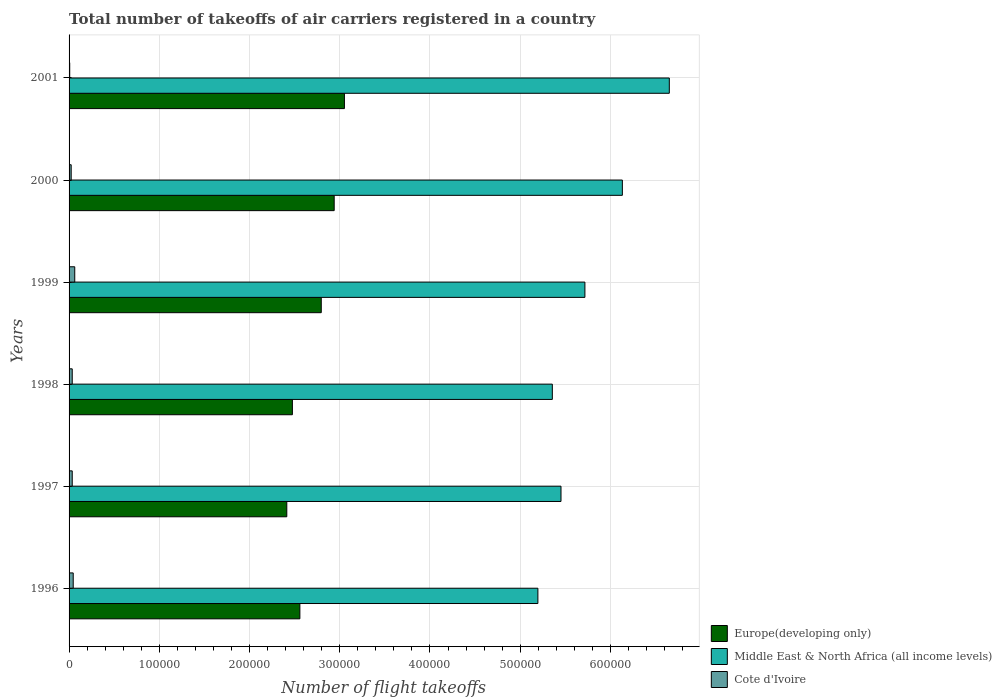How many groups of bars are there?
Offer a terse response. 6. Are the number of bars on each tick of the Y-axis equal?
Provide a succinct answer. Yes. How many bars are there on the 3rd tick from the top?
Your answer should be compact. 3. What is the total number of flight takeoffs in Europe(developing only) in 1996?
Offer a terse response. 2.56e+05. Across all years, what is the maximum total number of flight takeoffs in Middle East & North Africa (all income levels)?
Give a very brief answer. 6.65e+05. Across all years, what is the minimum total number of flight takeoffs in Middle East & North Africa (all income levels)?
Your answer should be compact. 5.20e+05. In which year was the total number of flight takeoffs in Cote d'Ivoire minimum?
Ensure brevity in your answer.  2001. What is the total total number of flight takeoffs in Middle East & North Africa (all income levels) in the graph?
Give a very brief answer. 3.45e+06. What is the difference between the total number of flight takeoffs in Cote d'Ivoire in 1997 and that in 1998?
Make the answer very short. 0. What is the difference between the total number of flight takeoffs in Europe(developing only) in 2000 and the total number of flight takeoffs in Cote d'Ivoire in 2001?
Your answer should be compact. 2.93e+05. What is the average total number of flight takeoffs in Middle East & North Africa (all income levels) per year?
Your response must be concise. 5.75e+05. In the year 1999, what is the difference between the total number of flight takeoffs in Europe(developing only) and total number of flight takeoffs in Middle East & North Africa (all income levels)?
Your response must be concise. -2.92e+05. What is the ratio of the total number of flight takeoffs in Middle East & North Africa (all income levels) in 1998 to that in 1999?
Make the answer very short. 0.94. Is the difference between the total number of flight takeoffs in Europe(developing only) in 1997 and 2001 greater than the difference between the total number of flight takeoffs in Middle East & North Africa (all income levels) in 1997 and 2001?
Make the answer very short. Yes. What is the difference between the highest and the second highest total number of flight takeoffs in Cote d'Ivoire?
Give a very brief answer. 1700. What is the difference between the highest and the lowest total number of flight takeoffs in Cote d'Ivoire?
Your answer should be very brief. 5584. What does the 2nd bar from the top in 1999 represents?
Provide a succinct answer. Middle East & North Africa (all income levels). What does the 3rd bar from the bottom in 1997 represents?
Your answer should be compact. Cote d'Ivoire. How many bars are there?
Offer a very short reply. 18. How many years are there in the graph?
Your answer should be very brief. 6. What is the difference between two consecutive major ticks on the X-axis?
Offer a terse response. 1.00e+05. Does the graph contain grids?
Offer a terse response. Yes. Where does the legend appear in the graph?
Your response must be concise. Bottom right. How many legend labels are there?
Provide a short and direct response. 3. How are the legend labels stacked?
Ensure brevity in your answer.  Vertical. What is the title of the graph?
Offer a very short reply. Total number of takeoffs of air carriers registered in a country. Does "New Zealand" appear as one of the legend labels in the graph?
Give a very brief answer. No. What is the label or title of the X-axis?
Give a very brief answer. Number of flight takeoffs. What is the Number of flight takeoffs in Europe(developing only) in 1996?
Offer a very short reply. 2.56e+05. What is the Number of flight takeoffs of Middle East & North Africa (all income levels) in 1996?
Keep it short and to the point. 5.20e+05. What is the Number of flight takeoffs in Cote d'Ivoire in 1996?
Your answer should be very brief. 4600. What is the Number of flight takeoffs of Europe(developing only) in 1997?
Ensure brevity in your answer.  2.41e+05. What is the Number of flight takeoffs of Middle East & North Africa (all income levels) in 1997?
Offer a very short reply. 5.45e+05. What is the Number of flight takeoffs in Cote d'Ivoire in 1997?
Ensure brevity in your answer.  3500. What is the Number of flight takeoffs of Europe(developing only) in 1998?
Make the answer very short. 2.48e+05. What is the Number of flight takeoffs in Middle East & North Africa (all income levels) in 1998?
Your answer should be compact. 5.36e+05. What is the Number of flight takeoffs of Cote d'Ivoire in 1998?
Make the answer very short. 3500. What is the Number of flight takeoffs of Europe(developing only) in 1999?
Your answer should be very brief. 2.80e+05. What is the Number of flight takeoffs in Middle East & North Africa (all income levels) in 1999?
Offer a terse response. 5.72e+05. What is the Number of flight takeoffs of Cote d'Ivoire in 1999?
Provide a succinct answer. 6300. What is the Number of flight takeoffs of Europe(developing only) in 2000?
Ensure brevity in your answer.  2.94e+05. What is the Number of flight takeoffs of Middle East & North Africa (all income levels) in 2000?
Offer a very short reply. 6.13e+05. What is the Number of flight takeoffs of Cote d'Ivoire in 2000?
Ensure brevity in your answer.  2342. What is the Number of flight takeoffs in Europe(developing only) in 2001?
Your response must be concise. 3.05e+05. What is the Number of flight takeoffs in Middle East & North Africa (all income levels) in 2001?
Give a very brief answer. 6.65e+05. What is the Number of flight takeoffs in Cote d'Ivoire in 2001?
Offer a terse response. 716. Across all years, what is the maximum Number of flight takeoffs of Europe(developing only)?
Provide a short and direct response. 3.05e+05. Across all years, what is the maximum Number of flight takeoffs in Middle East & North Africa (all income levels)?
Give a very brief answer. 6.65e+05. Across all years, what is the maximum Number of flight takeoffs in Cote d'Ivoire?
Make the answer very short. 6300. Across all years, what is the minimum Number of flight takeoffs of Europe(developing only)?
Provide a short and direct response. 2.41e+05. Across all years, what is the minimum Number of flight takeoffs in Middle East & North Africa (all income levels)?
Provide a short and direct response. 5.20e+05. Across all years, what is the minimum Number of flight takeoffs in Cote d'Ivoire?
Make the answer very short. 716. What is the total Number of flight takeoffs of Europe(developing only) in the graph?
Your response must be concise. 1.62e+06. What is the total Number of flight takeoffs of Middle East & North Africa (all income levels) in the graph?
Offer a very short reply. 3.45e+06. What is the total Number of flight takeoffs in Cote d'Ivoire in the graph?
Your response must be concise. 2.10e+04. What is the difference between the Number of flight takeoffs of Europe(developing only) in 1996 and that in 1997?
Offer a very short reply. 1.45e+04. What is the difference between the Number of flight takeoffs of Middle East & North Africa (all income levels) in 1996 and that in 1997?
Provide a short and direct response. -2.56e+04. What is the difference between the Number of flight takeoffs in Cote d'Ivoire in 1996 and that in 1997?
Make the answer very short. 1100. What is the difference between the Number of flight takeoffs of Europe(developing only) in 1996 and that in 1998?
Your response must be concise. 8300. What is the difference between the Number of flight takeoffs of Middle East & North Africa (all income levels) in 1996 and that in 1998?
Your answer should be very brief. -1.60e+04. What is the difference between the Number of flight takeoffs in Cote d'Ivoire in 1996 and that in 1998?
Your answer should be very brief. 1100. What is the difference between the Number of flight takeoffs of Europe(developing only) in 1996 and that in 1999?
Make the answer very short. -2.37e+04. What is the difference between the Number of flight takeoffs of Middle East & North Africa (all income levels) in 1996 and that in 1999?
Make the answer very short. -5.21e+04. What is the difference between the Number of flight takeoffs in Cote d'Ivoire in 1996 and that in 1999?
Ensure brevity in your answer.  -1700. What is the difference between the Number of flight takeoffs of Europe(developing only) in 1996 and that in 2000?
Keep it short and to the point. -3.80e+04. What is the difference between the Number of flight takeoffs in Middle East & North Africa (all income levels) in 1996 and that in 2000?
Your answer should be very brief. -9.36e+04. What is the difference between the Number of flight takeoffs in Cote d'Ivoire in 1996 and that in 2000?
Keep it short and to the point. 2258. What is the difference between the Number of flight takeoffs in Europe(developing only) in 1996 and that in 2001?
Make the answer very short. -4.94e+04. What is the difference between the Number of flight takeoffs of Middle East & North Africa (all income levels) in 1996 and that in 2001?
Ensure brevity in your answer.  -1.46e+05. What is the difference between the Number of flight takeoffs of Cote d'Ivoire in 1996 and that in 2001?
Give a very brief answer. 3884. What is the difference between the Number of flight takeoffs in Europe(developing only) in 1997 and that in 1998?
Ensure brevity in your answer.  -6200. What is the difference between the Number of flight takeoffs in Middle East & North Africa (all income levels) in 1997 and that in 1998?
Your response must be concise. 9600. What is the difference between the Number of flight takeoffs in Cote d'Ivoire in 1997 and that in 1998?
Your answer should be compact. 0. What is the difference between the Number of flight takeoffs of Europe(developing only) in 1997 and that in 1999?
Offer a terse response. -3.82e+04. What is the difference between the Number of flight takeoffs in Middle East & North Africa (all income levels) in 1997 and that in 1999?
Offer a very short reply. -2.65e+04. What is the difference between the Number of flight takeoffs in Cote d'Ivoire in 1997 and that in 1999?
Ensure brevity in your answer.  -2800. What is the difference between the Number of flight takeoffs of Europe(developing only) in 1997 and that in 2000?
Offer a terse response. -5.25e+04. What is the difference between the Number of flight takeoffs of Middle East & North Africa (all income levels) in 1997 and that in 2000?
Your answer should be very brief. -6.80e+04. What is the difference between the Number of flight takeoffs in Cote d'Ivoire in 1997 and that in 2000?
Your response must be concise. 1158. What is the difference between the Number of flight takeoffs in Europe(developing only) in 1997 and that in 2001?
Your answer should be very brief. -6.39e+04. What is the difference between the Number of flight takeoffs of Middle East & North Africa (all income levels) in 1997 and that in 2001?
Offer a very short reply. -1.20e+05. What is the difference between the Number of flight takeoffs in Cote d'Ivoire in 1997 and that in 2001?
Your response must be concise. 2784. What is the difference between the Number of flight takeoffs in Europe(developing only) in 1998 and that in 1999?
Provide a succinct answer. -3.20e+04. What is the difference between the Number of flight takeoffs in Middle East & North Africa (all income levels) in 1998 and that in 1999?
Make the answer very short. -3.61e+04. What is the difference between the Number of flight takeoffs of Cote d'Ivoire in 1998 and that in 1999?
Give a very brief answer. -2800. What is the difference between the Number of flight takeoffs in Europe(developing only) in 1998 and that in 2000?
Provide a succinct answer. -4.63e+04. What is the difference between the Number of flight takeoffs of Middle East & North Africa (all income levels) in 1998 and that in 2000?
Your response must be concise. -7.76e+04. What is the difference between the Number of flight takeoffs of Cote d'Ivoire in 1998 and that in 2000?
Your answer should be very brief. 1158. What is the difference between the Number of flight takeoffs in Europe(developing only) in 1998 and that in 2001?
Your answer should be very brief. -5.77e+04. What is the difference between the Number of flight takeoffs in Middle East & North Africa (all income levels) in 1998 and that in 2001?
Provide a succinct answer. -1.30e+05. What is the difference between the Number of flight takeoffs in Cote d'Ivoire in 1998 and that in 2001?
Your answer should be very brief. 2784. What is the difference between the Number of flight takeoffs of Europe(developing only) in 1999 and that in 2000?
Your answer should be compact. -1.43e+04. What is the difference between the Number of flight takeoffs in Middle East & North Africa (all income levels) in 1999 and that in 2000?
Ensure brevity in your answer.  -4.15e+04. What is the difference between the Number of flight takeoffs of Cote d'Ivoire in 1999 and that in 2000?
Offer a very short reply. 3958. What is the difference between the Number of flight takeoffs in Europe(developing only) in 1999 and that in 2001?
Provide a succinct answer. -2.57e+04. What is the difference between the Number of flight takeoffs in Middle East & North Africa (all income levels) in 1999 and that in 2001?
Your answer should be compact. -9.35e+04. What is the difference between the Number of flight takeoffs in Cote d'Ivoire in 1999 and that in 2001?
Offer a terse response. 5584. What is the difference between the Number of flight takeoffs in Europe(developing only) in 2000 and that in 2001?
Offer a terse response. -1.13e+04. What is the difference between the Number of flight takeoffs in Middle East & North Africa (all income levels) in 2000 and that in 2001?
Offer a very short reply. -5.20e+04. What is the difference between the Number of flight takeoffs of Cote d'Ivoire in 2000 and that in 2001?
Offer a terse response. 1626. What is the difference between the Number of flight takeoffs in Europe(developing only) in 1996 and the Number of flight takeoffs in Middle East & North Africa (all income levels) in 1997?
Your response must be concise. -2.89e+05. What is the difference between the Number of flight takeoffs in Europe(developing only) in 1996 and the Number of flight takeoffs in Cote d'Ivoire in 1997?
Your answer should be compact. 2.52e+05. What is the difference between the Number of flight takeoffs of Middle East & North Africa (all income levels) in 1996 and the Number of flight takeoffs of Cote d'Ivoire in 1997?
Provide a short and direct response. 5.16e+05. What is the difference between the Number of flight takeoffs in Europe(developing only) in 1996 and the Number of flight takeoffs in Middle East & North Africa (all income levels) in 1998?
Provide a short and direct response. -2.80e+05. What is the difference between the Number of flight takeoffs of Europe(developing only) in 1996 and the Number of flight takeoffs of Cote d'Ivoire in 1998?
Your answer should be very brief. 2.52e+05. What is the difference between the Number of flight takeoffs of Middle East & North Africa (all income levels) in 1996 and the Number of flight takeoffs of Cote d'Ivoire in 1998?
Your answer should be very brief. 5.16e+05. What is the difference between the Number of flight takeoffs in Europe(developing only) in 1996 and the Number of flight takeoffs in Middle East & North Africa (all income levels) in 1999?
Offer a very short reply. -3.16e+05. What is the difference between the Number of flight takeoffs in Europe(developing only) in 1996 and the Number of flight takeoffs in Cote d'Ivoire in 1999?
Provide a succinct answer. 2.50e+05. What is the difference between the Number of flight takeoffs in Middle East & North Africa (all income levels) in 1996 and the Number of flight takeoffs in Cote d'Ivoire in 1999?
Your response must be concise. 5.13e+05. What is the difference between the Number of flight takeoffs of Europe(developing only) in 1996 and the Number of flight takeoffs of Middle East & North Africa (all income levels) in 2000?
Offer a terse response. -3.57e+05. What is the difference between the Number of flight takeoffs of Europe(developing only) in 1996 and the Number of flight takeoffs of Cote d'Ivoire in 2000?
Keep it short and to the point. 2.53e+05. What is the difference between the Number of flight takeoffs of Middle East & North Africa (all income levels) in 1996 and the Number of flight takeoffs of Cote d'Ivoire in 2000?
Offer a terse response. 5.17e+05. What is the difference between the Number of flight takeoffs of Europe(developing only) in 1996 and the Number of flight takeoffs of Middle East & North Africa (all income levels) in 2001?
Ensure brevity in your answer.  -4.09e+05. What is the difference between the Number of flight takeoffs of Europe(developing only) in 1996 and the Number of flight takeoffs of Cote d'Ivoire in 2001?
Offer a very short reply. 2.55e+05. What is the difference between the Number of flight takeoffs of Middle East & North Africa (all income levels) in 1996 and the Number of flight takeoffs of Cote d'Ivoire in 2001?
Provide a succinct answer. 5.19e+05. What is the difference between the Number of flight takeoffs in Europe(developing only) in 1997 and the Number of flight takeoffs in Middle East & North Africa (all income levels) in 1998?
Ensure brevity in your answer.  -2.94e+05. What is the difference between the Number of flight takeoffs in Europe(developing only) in 1997 and the Number of flight takeoffs in Cote d'Ivoire in 1998?
Give a very brief answer. 2.38e+05. What is the difference between the Number of flight takeoffs of Middle East & North Africa (all income levels) in 1997 and the Number of flight takeoffs of Cote d'Ivoire in 1998?
Your response must be concise. 5.42e+05. What is the difference between the Number of flight takeoffs of Europe(developing only) in 1997 and the Number of flight takeoffs of Middle East & North Africa (all income levels) in 1999?
Give a very brief answer. -3.30e+05. What is the difference between the Number of flight takeoffs in Europe(developing only) in 1997 and the Number of flight takeoffs in Cote d'Ivoire in 1999?
Your answer should be very brief. 2.35e+05. What is the difference between the Number of flight takeoffs in Middle East & North Africa (all income levels) in 1997 and the Number of flight takeoffs in Cote d'Ivoire in 1999?
Your response must be concise. 5.39e+05. What is the difference between the Number of flight takeoffs of Europe(developing only) in 1997 and the Number of flight takeoffs of Middle East & North Africa (all income levels) in 2000?
Provide a short and direct response. -3.72e+05. What is the difference between the Number of flight takeoffs in Europe(developing only) in 1997 and the Number of flight takeoffs in Cote d'Ivoire in 2000?
Provide a short and direct response. 2.39e+05. What is the difference between the Number of flight takeoffs of Middle East & North Africa (all income levels) in 1997 and the Number of flight takeoffs of Cote d'Ivoire in 2000?
Keep it short and to the point. 5.43e+05. What is the difference between the Number of flight takeoffs of Europe(developing only) in 1997 and the Number of flight takeoffs of Middle East & North Africa (all income levels) in 2001?
Provide a short and direct response. -4.24e+05. What is the difference between the Number of flight takeoffs in Europe(developing only) in 1997 and the Number of flight takeoffs in Cote d'Ivoire in 2001?
Offer a very short reply. 2.41e+05. What is the difference between the Number of flight takeoffs of Middle East & North Africa (all income levels) in 1997 and the Number of flight takeoffs of Cote d'Ivoire in 2001?
Your answer should be very brief. 5.44e+05. What is the difference between the Number of flight takeoffs of Europe(developing only) in 1998 and the Number of flight takeoffs of Middle East & North Africa (all income levels) in 1999?
Offer a terse response. -3.24e+05. What is the difference between the Number of flight takeoffs in Europe(developing only) in 1998 and the Number of flight takeoffs in Cote d'Ivoire in 1999?
Make the answer very short. 2.41e+05. What is the difference between the Number of flight takeoffs in Middle East & North Africa (all income levels) in 1998 and the Number of flight takeoffs in Cote d'Ivoire in 1999?
Provide a short and direct response. 5.29e+05. What is the difference between the Number of flight takeoffs of Europe(developing only) in 1998 and the Number of flight takeoffs of Middle East & North Africa (all income levels) in 2000?
Provide a short and direct response. -3.66e+05. What is the difference between the Number of flight takeoffs of Europe(developing only) in 1998 and the Number of flight takeoffs of Cote d'Ivoire in 2000?
Provide a succinct answer. 2.45e+05. What is the difference between the Number of flight takeoffs in Middle East & North Africa (all income levels) in 1998 and the Number of flight takeoffs in Cote d'Ivoire in 2000?
Ensure brevity in your answer.  5.33e+05. What is the difference between the Number of flight takeoffs in Europe(developing only) in 1998 and the Number of flight takeoffs in Middle East & North Africa (all income levels) in 2001?
Keep it short and to the point. -4.18e+05. What is the difference between the Number of flight takeoffs of Europe(developing only) in 1998 and the Number of flight takeoffs of Cote d'Ivoire in 2001?
Your response must be concise. 2.47e+05. What is the difference between the Number of flight takeoffs in Middle East & North Africa (all income levels) in 1998 and the Number of flight takeoffs in Cote d'Ivoire in 2001?
Your response must be concise. 5.35e+05. What is the difference between the Number of flight takeoffs of Europe(developing only) in 1999 and the Number of flight takeoffs of Middle East & North Africa (all income levels) in 2000?
Provide a short and direct response. -3.34e+05. What is the difference between the Number of flight takeoffs of Europe(developing only) in 1999 and the Number of flight takeoffs of Cote d'Ivoire in 2000?
Provide a short and direct response. 2.77e+05. What is the difference between the Number of flight takeoffs in Middle East & North Africa (all income levels) in 1999 and the Number of flight takeoffs in Cote d'Ivoire in 2000?
Give a very brief answer. 5.69e+05. What is the difference between the Number of flight takeoffs in Europe(developing only) in 1999 and the Number of flight takeoffs in Middle East & North Africa (all income levels) in 2001?
Ensure brevity in your answer.  -3.86e+05. What is the difference between the Number of flight takeoffs in Europe(developing only) in 1999 and the Number of flight takeoffs in Cote d'Ivoire in 2001?
Offer a very short reply. 2.79e+05. What is the difference between the Number of flight takeoffs of Middle East & North Africa (all income levels) in 1999 and the Number of flight takeoffs of Cote d'Ivoire in 2001?
Provide a succinct answer. 5.71e+05. What is the difference between the Number of flight takeoffs in Europe(developing only) in 2000 and the Number of flight takeoffs in Middle East & North Africa (all income levels) in 2001?
Ensure brevity in your answer.  -3.71e+05. What is the difference between the Number of flight takeoffs in Europe(developing only) in 2000 and the Number of flight takeoffs in Cote d'Ivoire in 2001?
Ensure brevity in your answer.  2.93e+05. What is the difference between the Number of flight takeoffs in Middle East & North Africa (all income levels) in 2000 and the Number of flight takeoffs in Cote d'Ivoire in 2001?
Offer a terse response. 6.13e+05. What is the average Number of flight takeoffs of Europe(developing only) per year?
Offer a terse response. 2.71e+05. What is the average Number of flight takeoffs in Middle East & North Africa (all income levels) per year?
Provide a succinct answer. 5.75e+05. What is the average Number of flight takeoffs of Cote d'Ivoire per year?
Make the answer very short. 3493. In the year 1996, what is the difference between the Number of flight takeoffs in Europe(developing only) and Number of flight takeoffs in Middle East & North Africa (all income levels)?
Give a very brief answer. -2.64e+05. In the year 1996, what is the difference between the Number of flight takeoffs in Europe(developing only) and Number of flight takeoffs in Cote d'Ivoire?
Provide a succinct answer. 2.51e+05. In the year 1996, what is the difference between the Number of flight takeoffs of Middle East & North Africa (all income levels) and Number of flight takeoffs of Cote d'Ivoire?
Offer a very short reply. 5.15e+05. In the year 1997, what is the difference between the Number of flight takeoffs in Europe(developing only) and Number of flight takeoffs in Middle East & North Africa (all income levels)?
Offer a terse response. -3.04e+05. In the year 1997, what is the difference between the Number of flight takeoffs of Europe(developing only) and Number of flight takeoffs of Cote d'Ivoire?
Provide a succinct answer. 2.38e+05. In the year 1997, what is the difference between the Number of flight takeoffs in Middle East & North Africa (all income levels) and Number of flight takeoffs in Cote d'Ivoire?
Offer a terse response. 5.42e+05. In the year 1998, what is the difference between the Number of flight takeoffs in Europe(developing only) and Number of flight takeoffs in Middle East & North Africa (all income levels)?
Make the answer very short. -2.88e+05. In the year 1998, what is the difference between the Number of flight takeoffs in Europe(developing only) and Number of flight takeoffs in Cote d'Ivoire?
Provide a succinct answer. 2.44e+05. In the year 1998, what is the difference between the Number of flight takeoffs in Middle East & North Africa (all income levels) and Number of flight takeoffs in Cote d'Ivoire?
Offer a very short reply. 5.32e+05. In the year 1999, what is the difference between the Number of flight takeoffs in Europe(developing only) and Number of flight takeoffs in Middle East & North Africa (all income levels)?
Make the answer very short. -2.92e+05. In the year 1999, what is the difference between the Number of flight takeoffs in Europe(developing only) and Number of flight takeoffs in Cote d'Ivoire?
Offer a terse response. 2.73e+05. In the year 1999, what is the difference between the Number of flight takeoffs of Middle East & North Africa (all income levels) and Number of flight takeoffs of Cote d'Ivoire?
Your answer should be very brief. 5.65e+05. In the year 2000, what is the difference between the Number of flight takeoffs of Europe(developing only) and Number of flight takeoffs of Middle East & North Africa (all income levels)?
Your answer should be very brief. -3.19e+05. In the year 2000, what is the difference between the Number of flight takeoffs in Europe(developing only) and Number of flight takeoffs in Cote d'Ivoire?
Provide a short and direct response. 2.91e+05. In the year 2000, what is the difference between the Number of flight takeoffs of Middle East & North Africa (all income levels) and Number of flight takeoffs of Cote d'Ivoire?
Ensure brevity in your answer.  6.11e+05. In the year 2001, what is the difference between the Number of flight takeoffs of Europe(developing only) and Number of flight takeoffs of Middle East & North Africa (all income levels)?
Offer a terse response. -3.60e+05. In the year 2001, what is the difference between the Number of flight takeoffs of Europe(developing only) and Number of flight takeoffs of Cote d'Ivoire?
Your answer should be compact. 3.04e+05. In the year 2001, what is the difference between the Number of flight takeoffs of Middle East & North Africa (all income levels) and Number of flight takeoffs of Cote d'Ivoire?
Give a very brief answer. 6.65e+05. What is the ratio of the Number of flight takeoffs of Europe(developing only) in 1996 to that in 1997?
Your answer should be very brief. 1.06. What is the ratio of the Number of flight takeoffs of Middle East & North Africa (all income levels) in 1996 to that in 1997?
Keep it short and to the point. 0.95. What is the ratio of the Number of flight takeoffs of Cote d'Ivoire in 1996 to that in 1997?
Give a very brief answer. 1.31. What is the ratio of the Number of flight takeoffs in Europe(developing only) in 1996 to that in 1998?
Give a very brief answer. 1.03. What is the ratio of the Number of flight takeoffs in Middle East & North Africa (all income levels) in 1996 to that in 1998?
Provide a short and direct response. 0.97. What is the ratio of the Number of flight takeoffs of Cote d'Ivoire in 1996 to that in 1998?
Your answer should be very brief. 1.31. What is the ratio of the Number of flight takeoffs in Europe(developing only) in 1996 to that in 1999?
Make the answer very short. 0.92. What is the ratio of the Number of flight takeoffs of Middle East & North Africa (all income levels) in 1996 to that in 1999?
Provide a short and direct response. 0.91. What is the ratio of the Number of flight takeoffs in Cote d'Ivoire in 1996 to that in 1999?
Your response must be concise. 0.73. What is the ratio of the Number of flight takeoffs in Europe(developing only) in 1996 to that in 2000?
Make the answer very short. 0.87. What is the ratio of the Number of flight takeoffs of Middle East & North Africa (all income levels) in 1996 to that in 2000?
Offer a terse response. 0.85. What is the ratio of the Number of flight takeoffs in Cote d'Ivoire in 1996 to that in 2000?
Provide a short and direct response. 1.96. What is the ratio of the Number of flight takeoffs in Europe(developing only) in 1996 to that in 2001?
Provide a succinct answer. 0.84. What is the ratio of the Number of flight takeoffs of Middle East & North Africa (all income levels) in 1996 to that in 2001?
Your answer should be very brief. 0.78. What is the ratio of the Number of flight takeoffs of Cote d'Ivoire in 1996 to that in 2001?
Your answer should be compact. 6.42. What is the ratio of the Number of flight takeoffs of Europe(developing only) in 1997 to that in 1998?
Offer a terse response. 0.97. What is the ratio of the Number of flight takeoffs in Middle East & North Africa (all income levels) in 1997 to that in 1998?
Your response must be concise. 1.02. What is the ratio of the Number of flight takeoffs in Europe(developing only) in 1997 to that in 1999?
Your response must be concise. 0.86. What is the ratio of the Number of flight takeoffs in Middle East & North Africa (all income levels) in 1997 to that in 1999?
Offer a terse response. 0.95. What is the ratio of the Number of flight takeoffs in Cote d'Ivoire in 1997 to that in 1999?
Provide a succinct answer. 0.56. What is the ratio of the Number of flight takeoffs of Europe(developing only) in 1997 to that in 2000?
Keep it short and to the point. 0.82. What is the ratio of the Number of flight takeoffs in Middle East & North Africa (all income levels) in 1997 to that in 2000?
Provide a short and direct response. 0.89. What is the ratio of the Number of flight takeoffs in Cote d'Ivoire in 1997 to that in 2000?
Make the answer very short. 1.49. What is the ratio of the Number of flight takeoffs of Europe(developing only) in 1997 to that in 2001?
Provide a short and direct response. 0.79. What is the ratio of the Number of flight takeoffs in Middle East & North Africa (all income levels) in 1997 to that in 2001?
Give a very brief answer. 0.82. What is the ratio of the Number of flight takeoffs in Cote d'Ivoire in 1997 to that in 2001?
Keep it short and to the point. 4.89. What is the ratio of the Number of flight takeoffs of Europe(developing only) in 1998 to that in 1999?
Provide a succinct answer. 0.89. What is the ratio of the Number of flight takeoffs in Middle East & North Africa (all income levels) in 1998 to that in 1999?
Make the answer very short. 0.94. What is the ratio of the Number of flight takeoffs in Cote d'Ivoire in 1998 to that in 1999?
Provide a short and direct response. 0.56. What is the ratio of the Number of flight takeoffs in Europe(developing only) in 1998 to that in 2000?
Provide a succinct answer. 0.84. What is the ratio of the Number of flight takeoffs in Middle East & North Africa (all income levels) in 1998 to that in 2000?
Ensure brevity in your answer.  0.87. What is the ratio of the Number of flight takeoffs in Cote d'Ivoire in 1998 to that in 2000?
Provide a succinct answer. 1.49. What is the ratio of the Number of flight takeoffs in Europe(developing only) in 1998 to that in 2001?
Your answer should be very brief. 0.81. What is the ratio of the Number of flight takeoffs in Middle East & North Africa (all income levels) in 1998 to that in 2001?
Provide a succinct answer. 0.81. What is the ratio of the Number of flight takeoffs of Cote d'Ivoire in 1998 to that in 2001?
Ensure brevity in your answer.  4.89. What is the ratio of the Number of flight takeoffs of Europe(developing only) in 1999 to that in 2000?
Offer a terse response. 0.95. What is the ratio of the Number of flight takeoffs of Middle East & North Africa (all income levels) in 1999 to that in 2000?
Your answer should be very brief. 0.93. What is the ratio of the Number of flight takeoffs of Cote d'Ivoire in 1999 to that in 2000?
Offer a very short reply. 2.69. What is the ratio of the Number of flight takeoffs in Europe(developing only) in 1999 to that in 2001?
Offer a very short reply. 0.92. What is the ratio of the Number of flight takeoffs in Middle East & North Africa (all income levels) in 1999 to that in 2001?
Provide a short and direct response. 0.86. What is the ratio of the Number of flight takeoffs of Cote d'Ivoire in 1999 to that in 2001?
Offer a very short reply. 8.8. What is the ratio of the Number of flight takeoffs of Europe(developing only) in 2000 to that in 2001?
Provide a succinct answer. 0.96. What is the ratio of the Number of flight takeoffs in Middle East & North Africa (all income levels) in 2000 to that in 2001?
Your answer should be compact. 0.92. What is the ratio of the Number of flight takeoffs in Cote d'Ivoire in 2000 to that in 2001?
Offer a very short reply. 3.27. What is the difference between the highest and the second highest Number of flight takeoffs in Europe(developing only)?
Your answer should be very brief. 1.13e+04. What is the difference between the highest and the second highest Number of flight takeoffs in Middle East & North Africa (all income levels)?
Make the answer very short. 5.20e+04. What is the difference between the highest and the second highest Number of flight takeoffs of Cote d'Ivoire?
Give a very brief answer. 1700. What is the difference between the highest and the lowest Number of flight takeoffs in Europe(developing only)?
Your answer should be compact. 6.39e+04. What is the difference between the highest and the lowest Number of flight takeoffs in Middle East & North Africa (all income levels)?
Give a very brief answer. 1.46e+05. What is the difference between the highest and the lowest Number of flight takeoffs of Cote d'Ivoire?
Keep it short and to the point. 5584. 